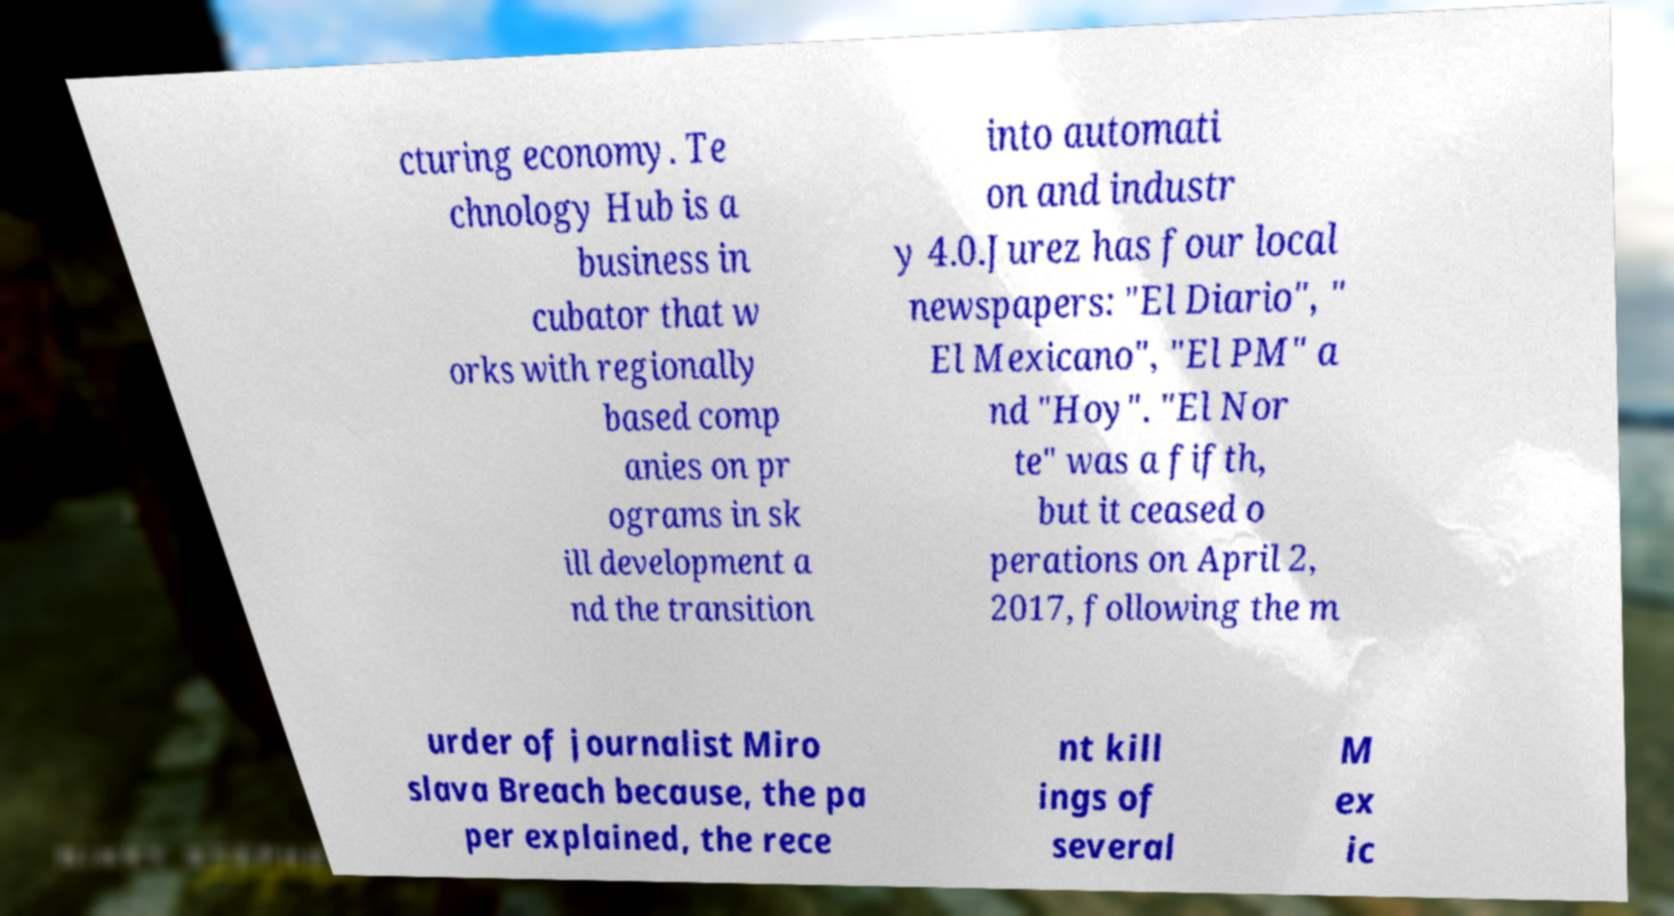Can you accurately transcribe the text from the provided image for me? cturing economy. Te chnology Hub is a business in cubator that w orks with regionally based comp anies on pr ograms in sk ill development a nd the transition into automati on and industr y 4.0.Jurez has four local newspapers: "El Diario", " El Mexicano", "El PM" a nd "Hoy". "El Nor te" was a fifth, but it ceased o perations on April 2, 2017, following the m urder of journalist Miro slava Breach because, the pa per explained, the rece nt kill ings of several M ex ic 